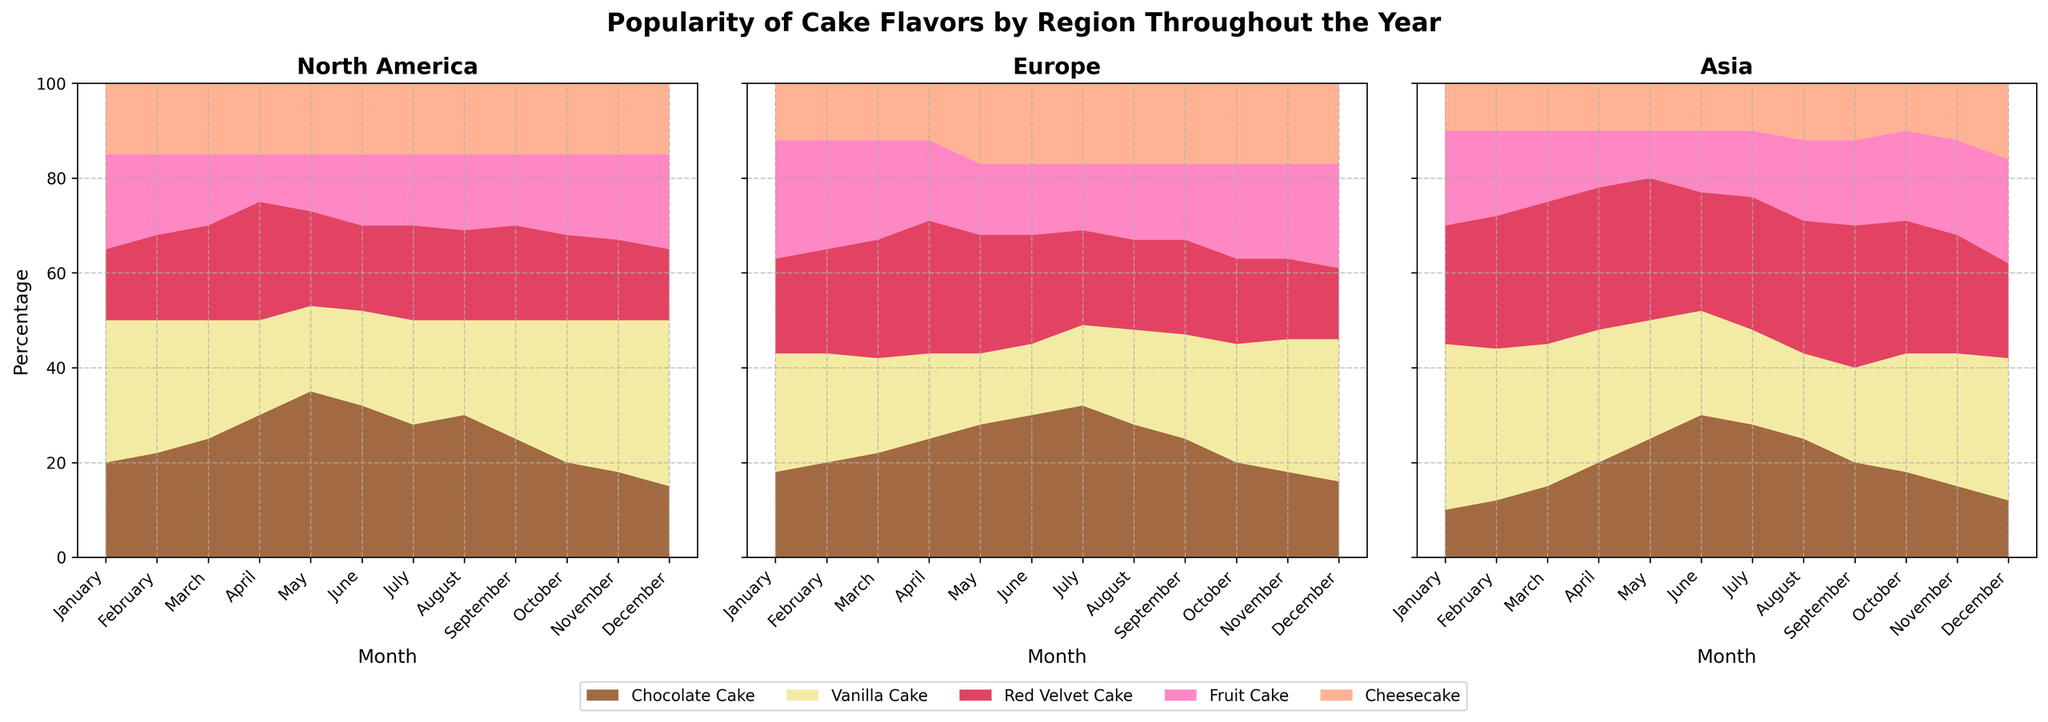What is the title of the figure? The title of the figure is typically at the top and provides a brief description of the chart. It's labeled as 'Popularity of Cake Flavors by Region Throughout the Year'.
Answer: Popularity of Cake Flavors by Region Throughout the Year Which cake flavor is consistently most popular in Asia throughout the year? The regions are divided into subplots, with Asia being one of them. By observing the stacked areas, the largest section, consistently colored the same, depicts the most popular cake flavor. Vanilla Cake appears consistently most prominent in Asia.
Answer: Vanilla Cake During which month does Chocolate Cake have the highest percentage in Europe? The subplot for Europe should be observed. By following Chocolate Cake's color (brown) along the months on the x-axis, the highest percentage is at its peak in June.
Answer: June Which region shows the smallest variation in the popularity of Cheesecake throughout the year? Comparing all subplots, observe the Cheesecake section in each, which is colored light orange. The region with the most consistent area size for Cheesecake should be identified. North America's subplot shows Cheesecake's area remaining relatively stable.
Answer: North America In which month does Fruit Cake peak in North America? The subplot for North America should be examined, focusing on Fruit Cake's color (pink). Locate the month where the pink section is most prominent, which is December.
Answer: December Compare Chocolate Cake's popularity trend between North America and Europe. In North America's subplot, Chocolate Cake's (brown) area generally increases from January to May, then slightly decreases. In Europe's subplot, the brown area increases steadily until July, then decreases.
Answer: Increases until May in North America, increases until July in Europe What is the least popular cake flavor in September in Asia? In the subplot for Asia, observe the month of September and identify the smallest section. Cheesecake (light orange) is the smallest, indicating it is the least popular for that month.
Answer: Cheesecake Does Vanilla Cake ever become the least popular in any month in North America? In North America's subplot, follow Vanilla Cake's color (yellow) across all months. It remains among the largest sections and never appears as the least significant area.
Answer: No Which region sees a peak in the contribution of Red Velvet Cake in April? Examine each subplot for April and observe Red Velvet Cake's color (deep red). Europe shows a larger spike compared to the other regions.
Answer: Europe In December, compare the proportion of Red Velvet Cake between Europe and Asia. Look at the December data points for both Europe and Asia subplots, focusing on the red section. Europe shows a larger proportion of Red Velvet Cake than Asia.
Answer: Europe has a larger proportion 